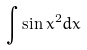Convert formula to latex. <formula><loc_0><loc_0><loc_500><loc_500>\int \sin x ^ { 2 } d x</formula> 